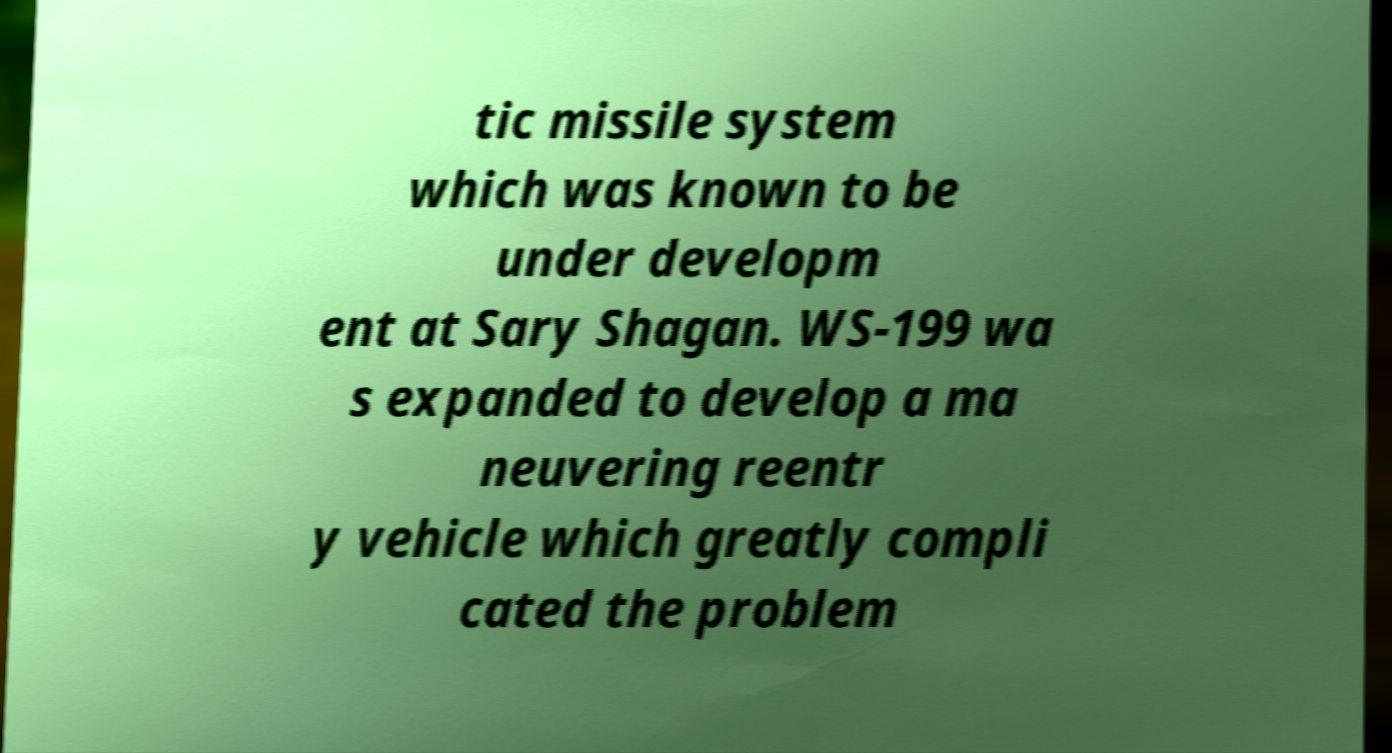Could you assist in decoding the text presented in this image and type it out clearly? tic missile system which was known to be under developm ent at Sary Shagan. WS-199 wa s expanded to develop a ma neuvering reentr y vehicle which greatly compli cated the problem 